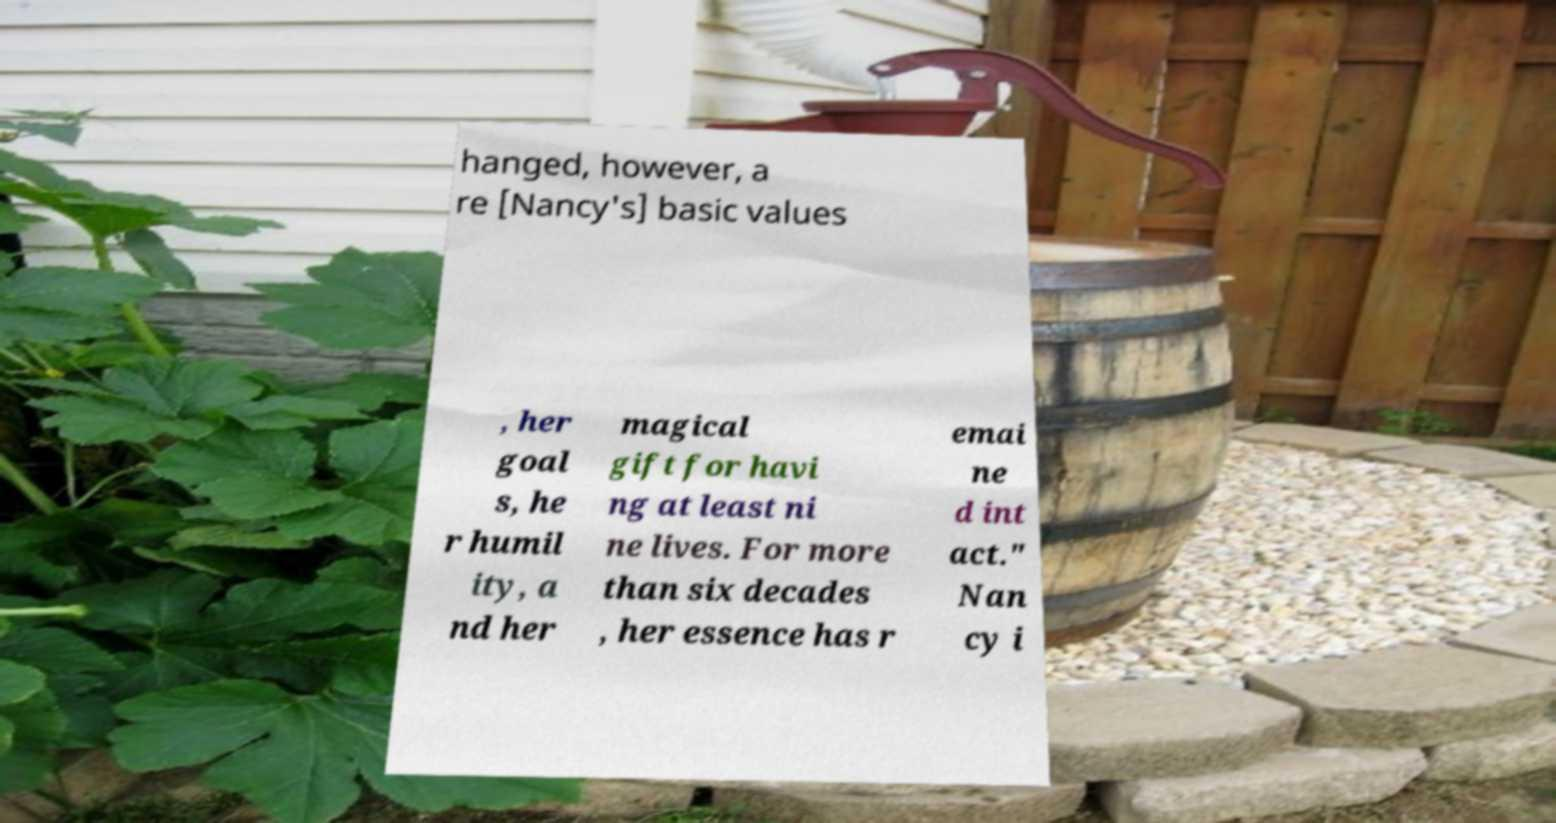Can you accurately transcribe the text from the provided image for me? hanged, however, a re [Nancy's] basic values , her goal s, he r humil ity, a nd her magical gift for havi ng at least ni ne lives. For more than six decades , her essence has r emai ne d int act." Nan cy i 